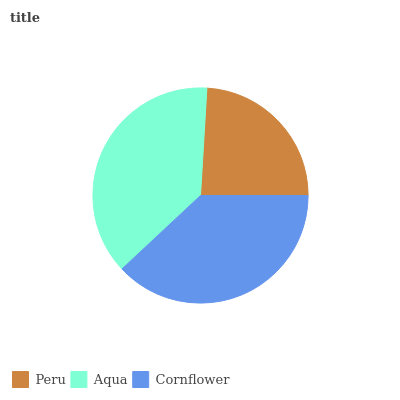Is Peru the minimum?
Answer yes or no. Yes. Is Cornflower the maximum?
Answer yes or no. Yes. Is Aqua the minimum?
Answer yes or no. No. Is Aqua the maximum?
Answer yes or no. No. Is Aqua greater than Peru?
Answer yes or no. Yes. Is Peru less than Aqua?
Answer yes or no. Yes. Is Peru greater than Aqua?
Answer yes or no. No. Is Aqua less than Peru?
Answer yes or no. No. Is Aqua the high median?
Answer yes or no. Yes. Is Aqua the low median?
Answer yes or no. Yes. Is Cornflower the high median?
Answer yes or no. No. Is Peru the low median?
Answer yes or no. No. 